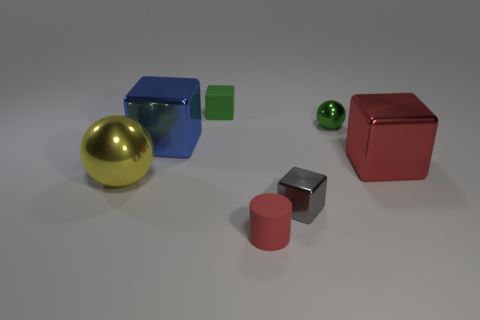Can you describe the colors and shapes of the objects on the left side of the image? On the left side of the image, there is a large, shiny gold sphere and a semi-transparent blue cube, both resting on the surface.  How does the lighting in the scene affect the appearance of the objects? The scene is lit from above, casting soft shadows behind the objects. The lighting accentuates the reflective quality of the glossy objects and the translucence of the semi-transparent ones, giving a sense of depth and texture. 